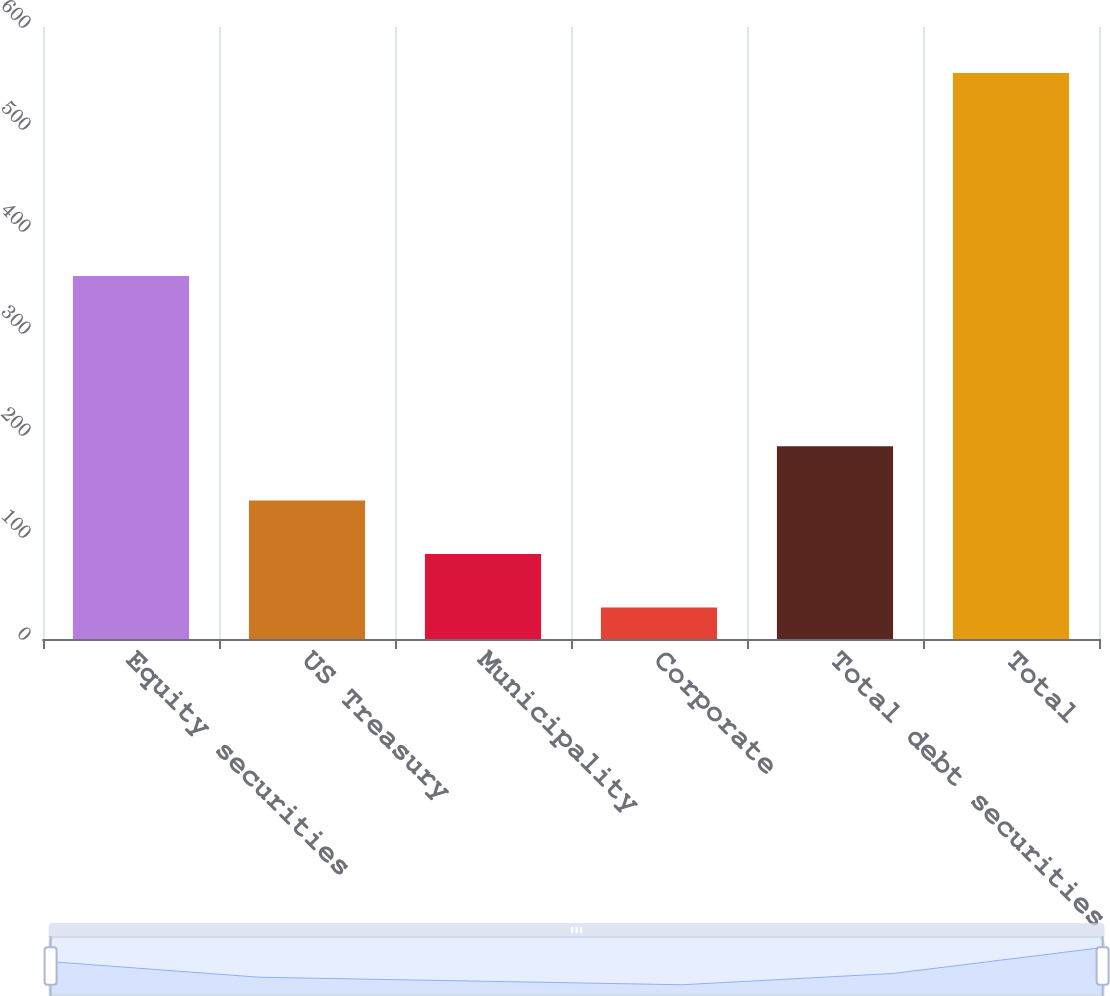Convert chart. <chart><loc_0><loc_0><loc_500><loc_500><bar_chart><fcel>Equity securities<fcel>US Treasury<fcel>Municipality<fcel>Corporate<fcel>Total debt securities<fcel>Total<nl><fcel>356<fcel>135.8<fcel>83.4<fcel>31<fcel>189<fcel>555<nl></chart> 